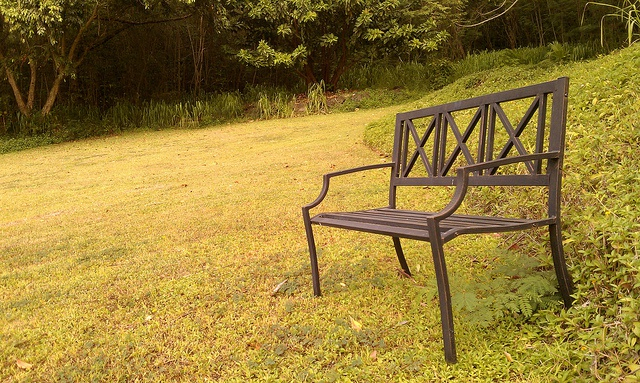Describe the objects in this image and their specific colors. I can see a bench in khaki, gray, maroon, and tan tones in this image. 